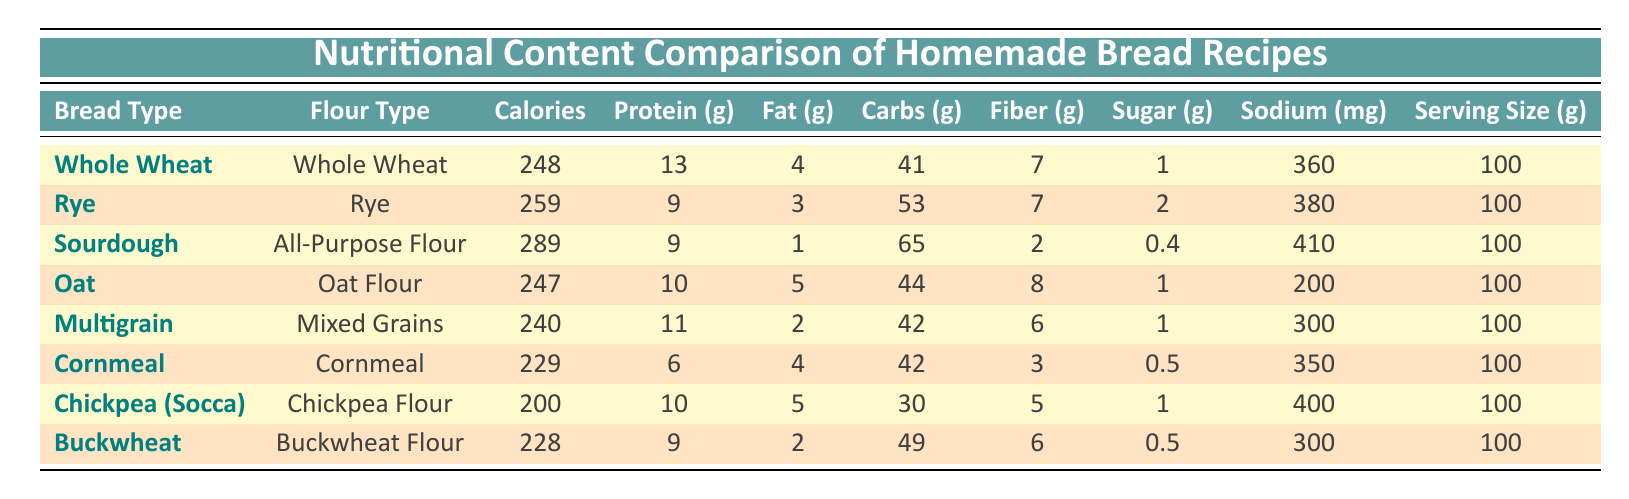What is the calorie content of Oat Bread? Oat Bread is listed in the table, and its calorie content is directly provided, which is 247 calories per 100g serving.
Answer: 247 calories Which bread has the highest protein content? By reviewing the protein values for each bread recipe, Whole Wheat Bread has the highest protein content with 13g per 100g serving.
Answer: Whole Wheat Bread Is Sourdough bread lower in fat than Multigrain bread? Sourdough Bread has 1g of fat, while Multigrain Bread has 2g of fat. Since 1g is less than 2g, Sourdough is indeed lower in fat than Multigrain.
Answer: Yes What is the total carbohydrate content in Rye Bread and Cornmeal Bread combined? The carbohydrate content for Rye Bread is 53g and for Cornmeal Bread is 42g. Adding these values together gives 53 + 42 = 95g of carbohydrates.
Answer: 95g What percentage of calories from fat does Chickpea Bread have compared to its total calories? Chickpea Bread has 200 calories and 5g of fat. The calories from fat can be calculated as 5g fat * 9 calories/g = 45 calories. The percentage is (45/200)*100 = 22.5%.
Answer: 22.5% Which bread type has the highest fiber content and what is that value? By checking the fiber contents listed, Oat Bread has the highest fiber content with 8g per 100g serving.
Answer: Oat Bread, 8g What is the average sodium content of all the bread recipes? The sodium values for all breads are 360, 380, 410, 200, 300, 350, 400, and 300 mg. Adding these together gives 360 + 380 + 410 + 200 + 300 + 350 + 400 + 300 = 2700 mg. Then, divide by 8 (since there are 8 bread recipes), which is 2700 / 8 = 337.5 mg.
Answer: 337.5 mg Does any bread have a sugar content of 0g? Looking through the sugar contents provided, Sourdough Bread has 0.4g of sugar, which is the least but still above 0g, hence no bread has exactly 0g.
Answer: No If a person were to consume one serving of Buckwheat Bread, how much fiber would they intake? Buckwheat Bread has a fiber content of 6g per 100g serving as per the table.
Answer: 6g Which two types of bread have the lowest calorie content, and what are their calorie values? The two types of bread with the lowest calories are Cornmeal Bread with 229 calories and Chickpea Bread with 200 calories.
Answer: Cornmeal Bread (229 calories), Chickpea Bread (200 calories) 